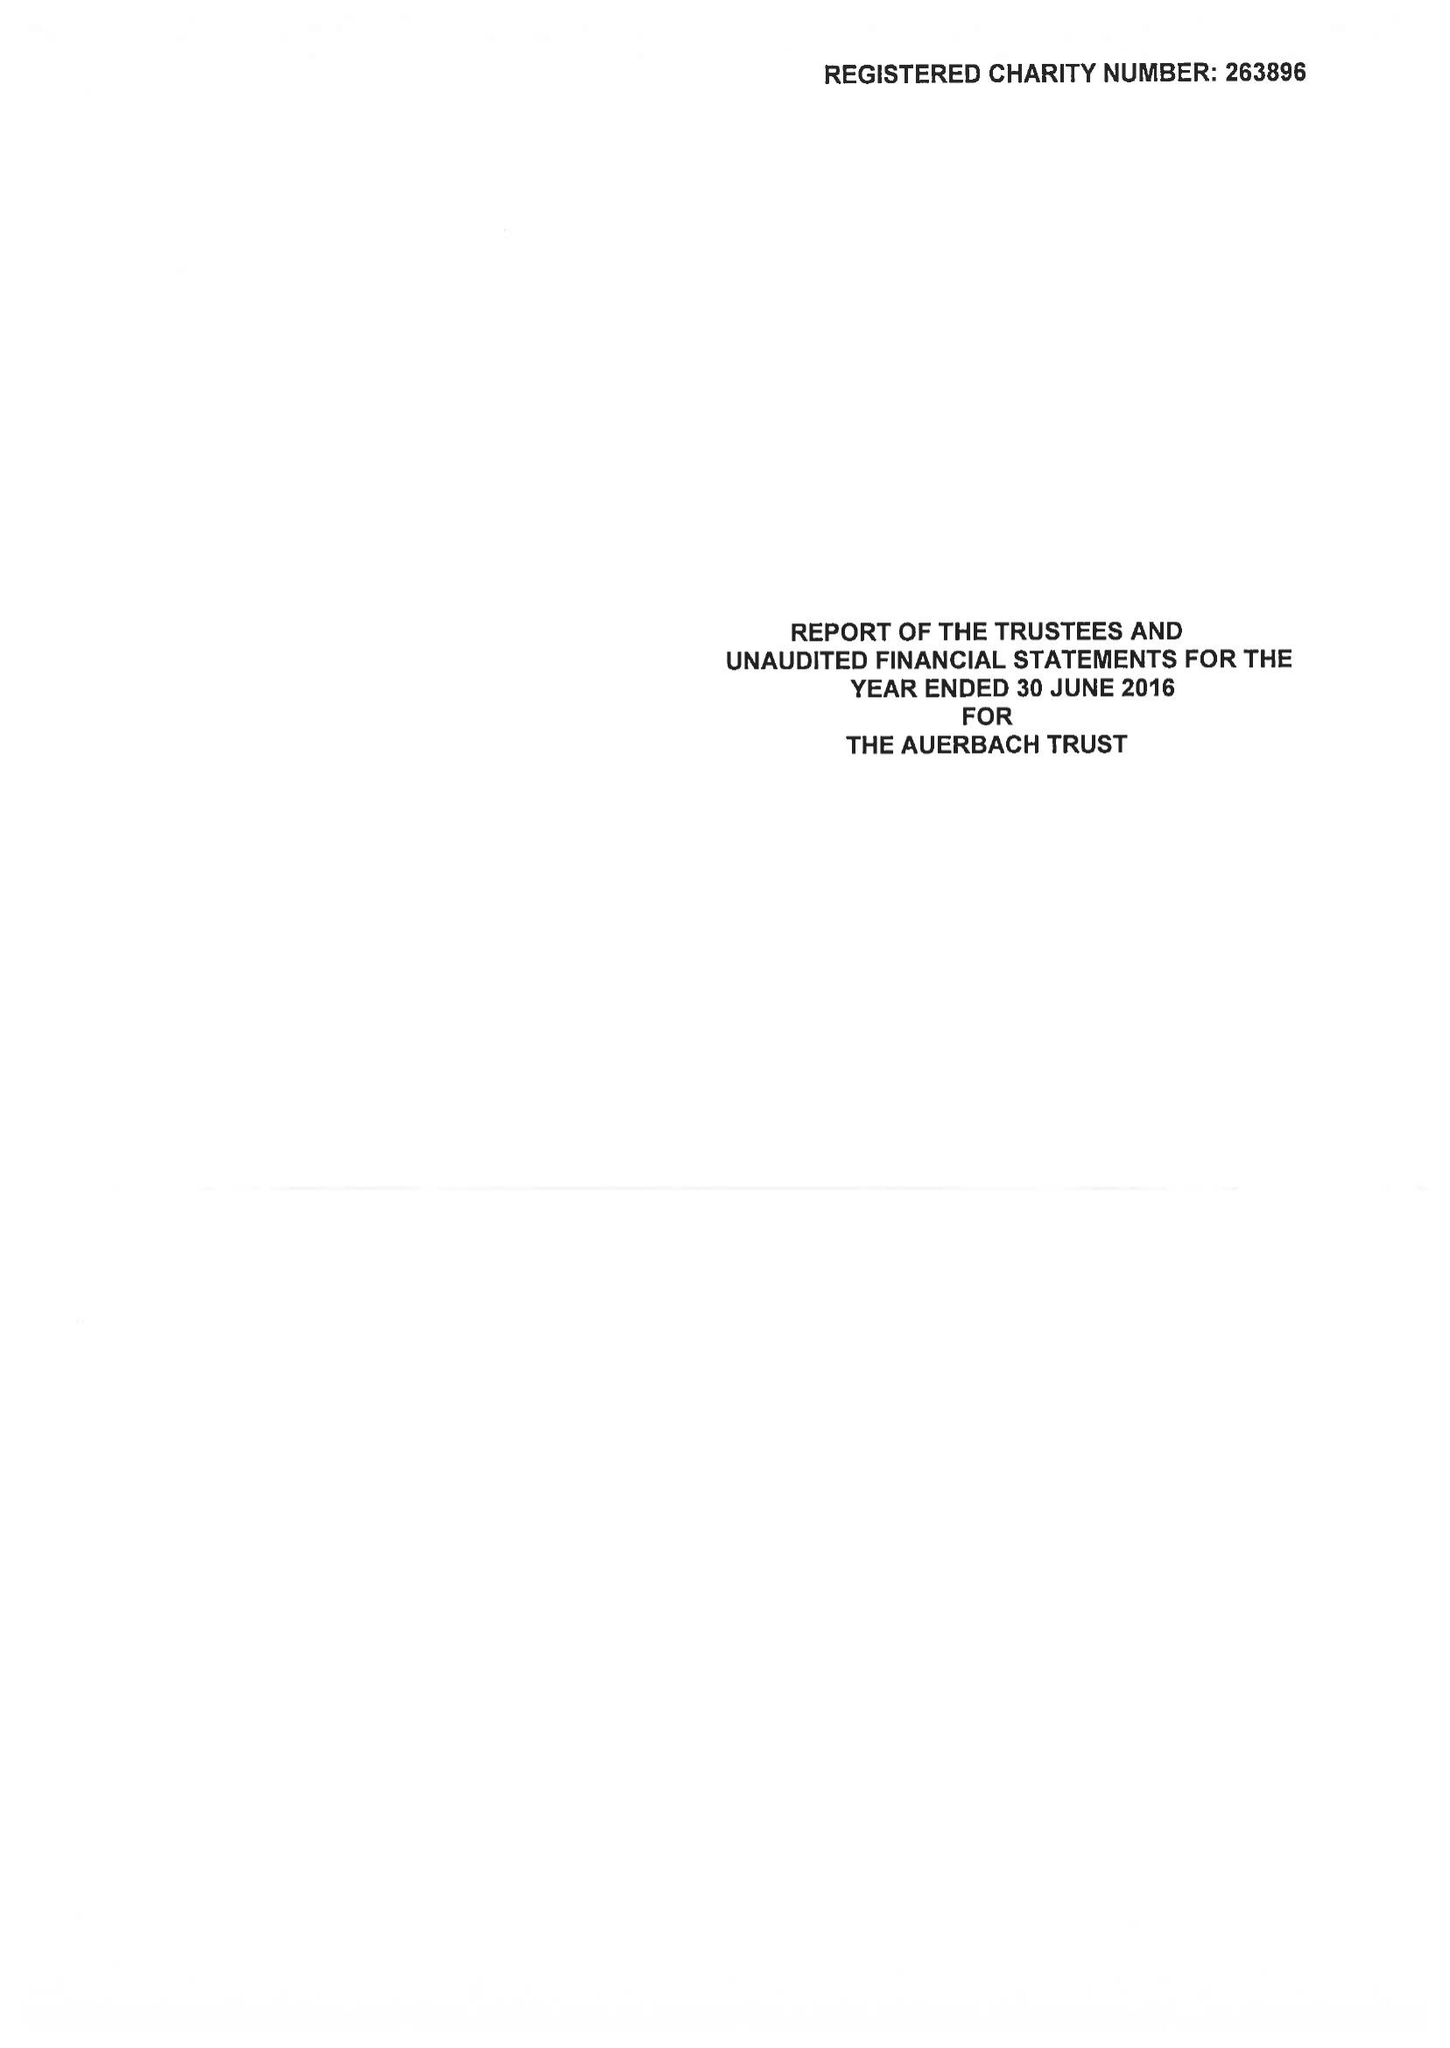What is the value for the charity_number?
Answer the question using a single word or phrase. 263896 